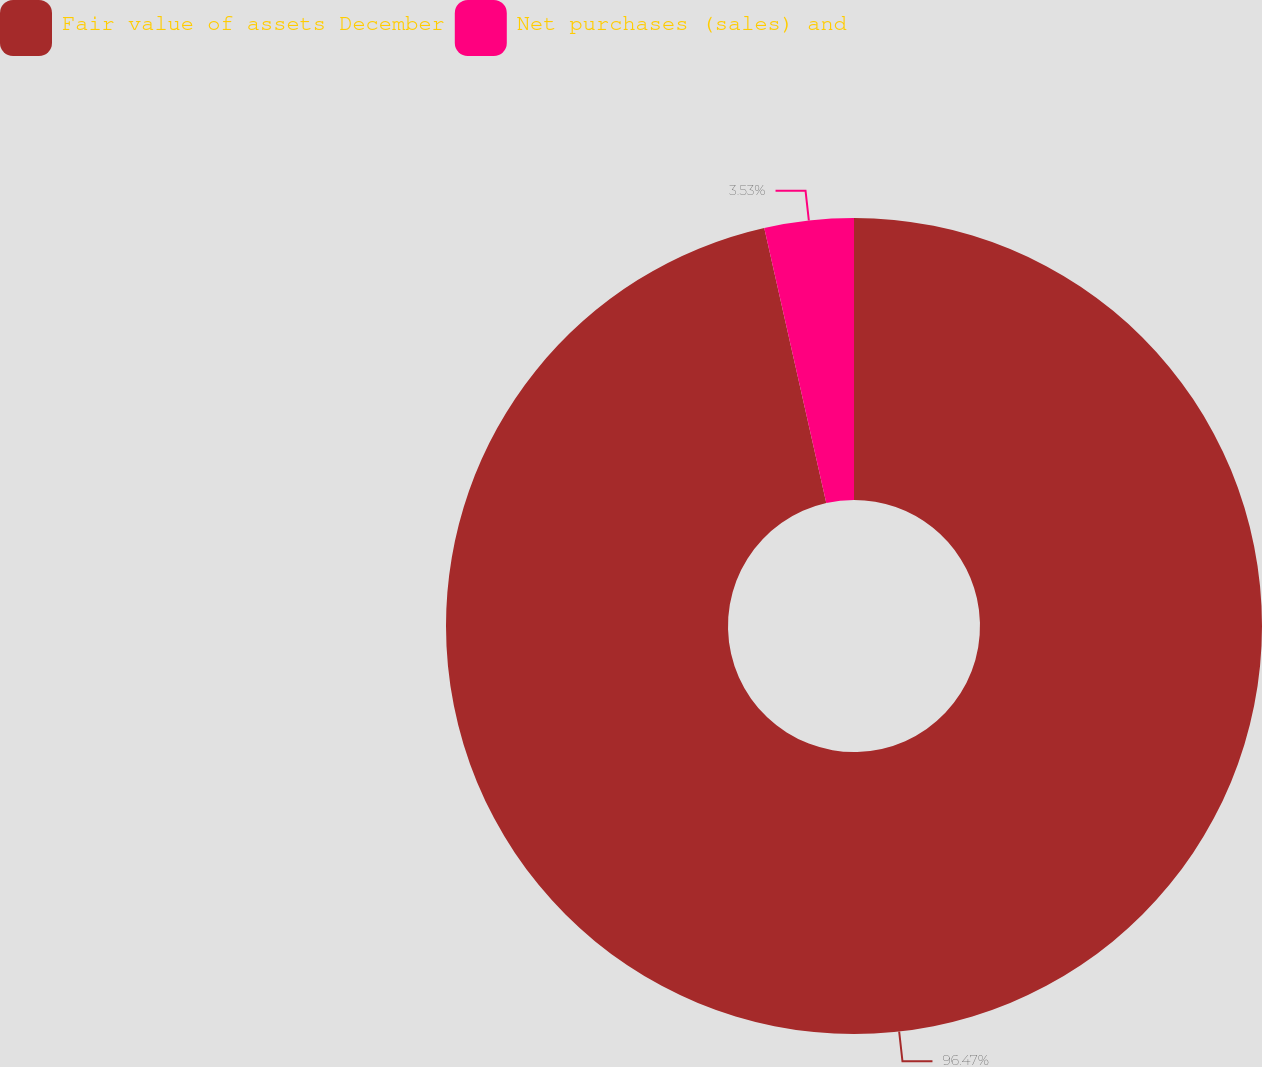Convert chart. <chart><loc_0><loc_0><loc_500><loc_500><pie_chart><fcel>Fair value of assets December<fcel>Net purchases (sales) and<nl><fcel>96.47%<fcel>3.53%<nl></chart> 